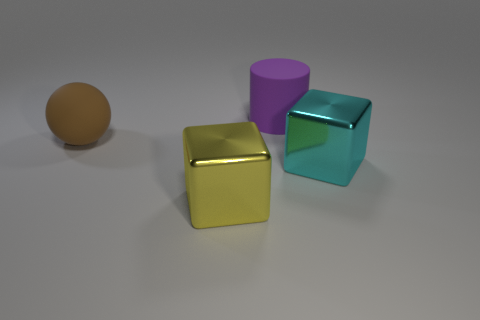Add 4 cyan blocks. How many objects exist? 8 Subtract all balls. How many objects are left? 3 Add 4 yellow shiny cubes. How many yellow shiny cubes exist? 5 Subtract 0 yellow cylinders. How many objects are left? 4 Subtract all small brown cubes. Subtract all large yellow metal cubes. How many objects are left? 3 Add 3 big balls. How many big balls are left? 4 